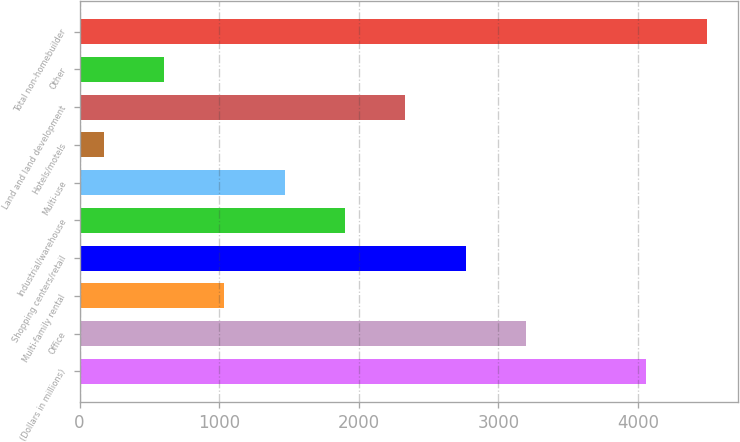Convert chart to OTSL. <chart><loc_0><loc_0><loc_500><loc_500><bar_chart><fcel>(Dollars in millions)<fcel>Office<fcel>Multi-family rental<fcel>Shopping centers/retail<fcel>Industrial/warehouse<fcel>Multi-use<fcel>Hotels/motels<fcel>Land and land development<fcel>Other<fcel>Total non-homebuilder<nl><fcel>4060.1<fcel>3196.3<fcel>1036.8<fcel>2764.4<fcel>1900.6<fcel>1468.7<fcel>173<fcel>2332.5<fcel>604.9<fcel>4492<nl></chart> 